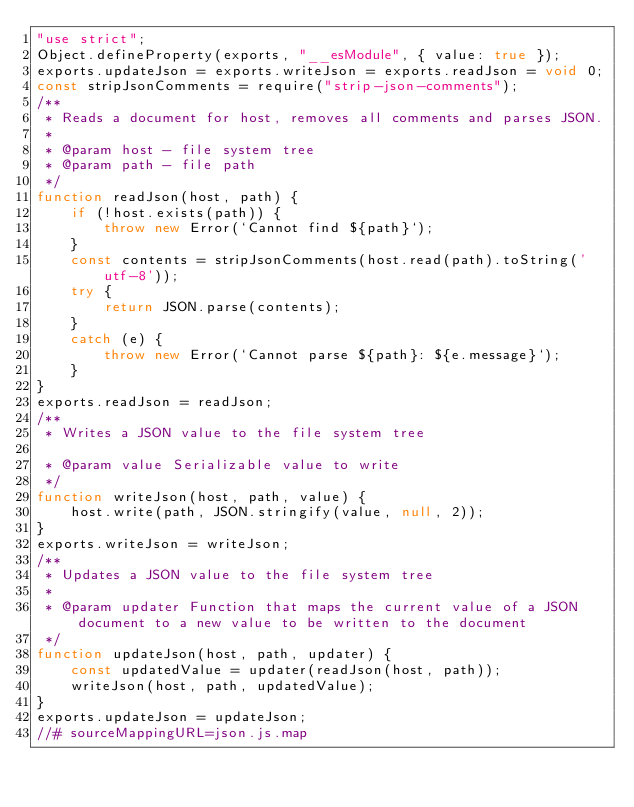<code> <loc_0><loc_0><loc_500><loc_500><_JavaScript_>"use strict";
Object.defineProperty(exports, "__esModule", { value: true });
exports.updateJson = exports.writeJson = exports.readJson = void 0;
const stripJsonComments = require("strip-json-comments");
/**
 * Reads a document for host, removes all comments and parses JSON.
 *
 * @param host - file system tree
 * @param path - file path
 */
function readJson(host, path) {
    if (!host.exists(path)) {
        throw new Error(`Cannot find ${path}`);
    }
    const contents = stripJsonComments(host.read(path).toString('utf-8'));
    try {
        return JSON.parse(contents);
    }
    catch (e) {
        throw new Error(`Cannot parse ${path}: ${e.message}`);
    }
}
exports.readJson = readJson;
/**
 * Writes a JSON value to the file system tree

 * @param value Serializable value to write
 */
function writeJson(host, path, value) {
    host.write(path, JSON.stringify(value, null, 2));
}
exports.writeJson = writeJson;
/**
 * Updates a JSON value to the file system tree
 *
 * @param updater Function that maps the current value of a JSON document to a new value to be written to the document
 */
function updateJson(host, path, updater) {
    const updatedValue = updater(readJson(host, path));
    writeJson(host, path, updatedValue);
}
exports.updateJson = updateJson;
//# sourceMappingURL=json.js.map</code> 